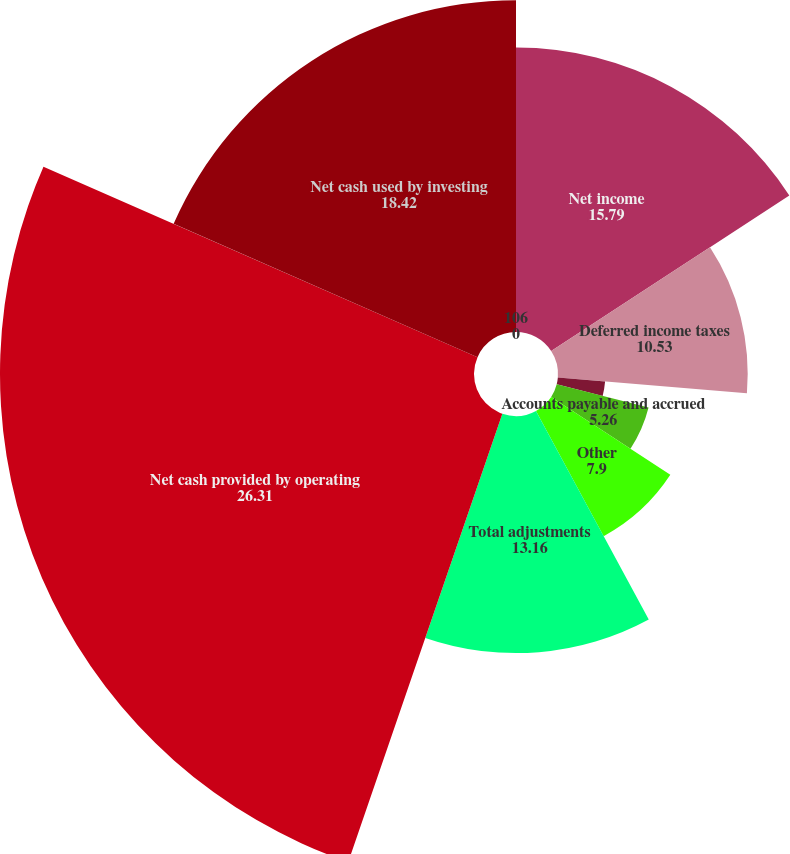Convert chart. <chart><loc_0><loc_0><loc_500><loc_500><pie_chart><fcel>Net income<fcel>Deferred income taxes<fcel>Other net<fcel>Accounts payable and accrued<fcel>Other<fcel>Total adjustments<fcel>Net cash provided by operating<fcel>Net cash used by investing<fcel>106<nl><fcel>15.79%<fcel>10.53%<fcel>2.63%<fcel>5.26%<fcel>7.9%<fcel>13.16%<fcel>26.31%<fcel>18.42%<fcel>0.0%<nl></chart> 